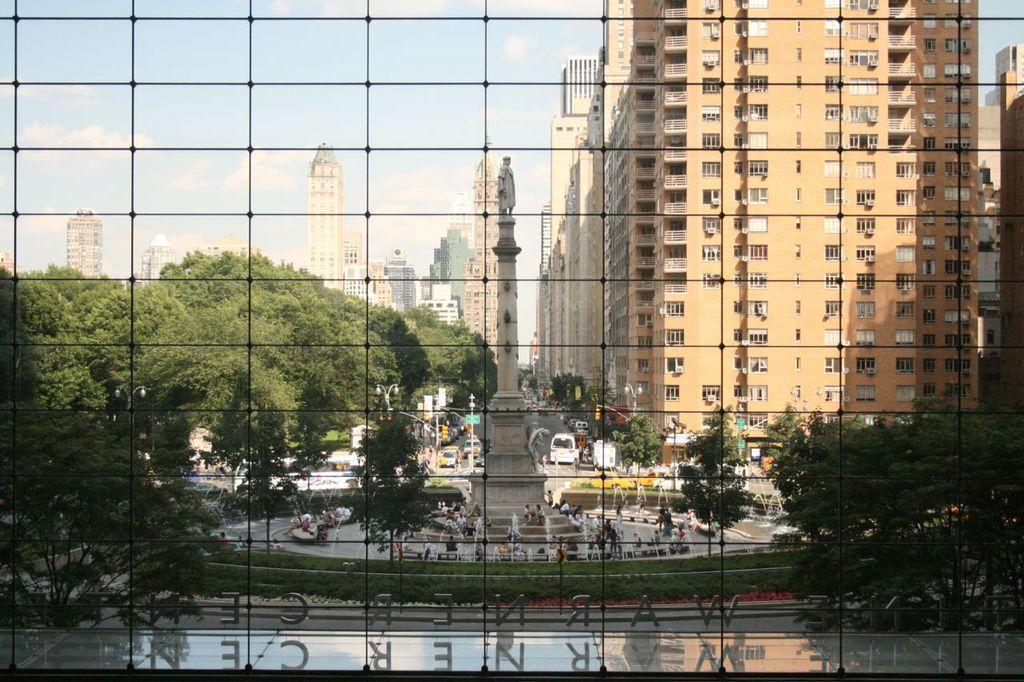Can you describe this image briefly? In this image in front there is a metal fence. Behind the metal fence there are letters on the platform. In the center of the image there is a statue. There are people sitting on the benches. There are fountains. There are vehicles on the road. There are trees. In the background of the image there are buildings and sky. 